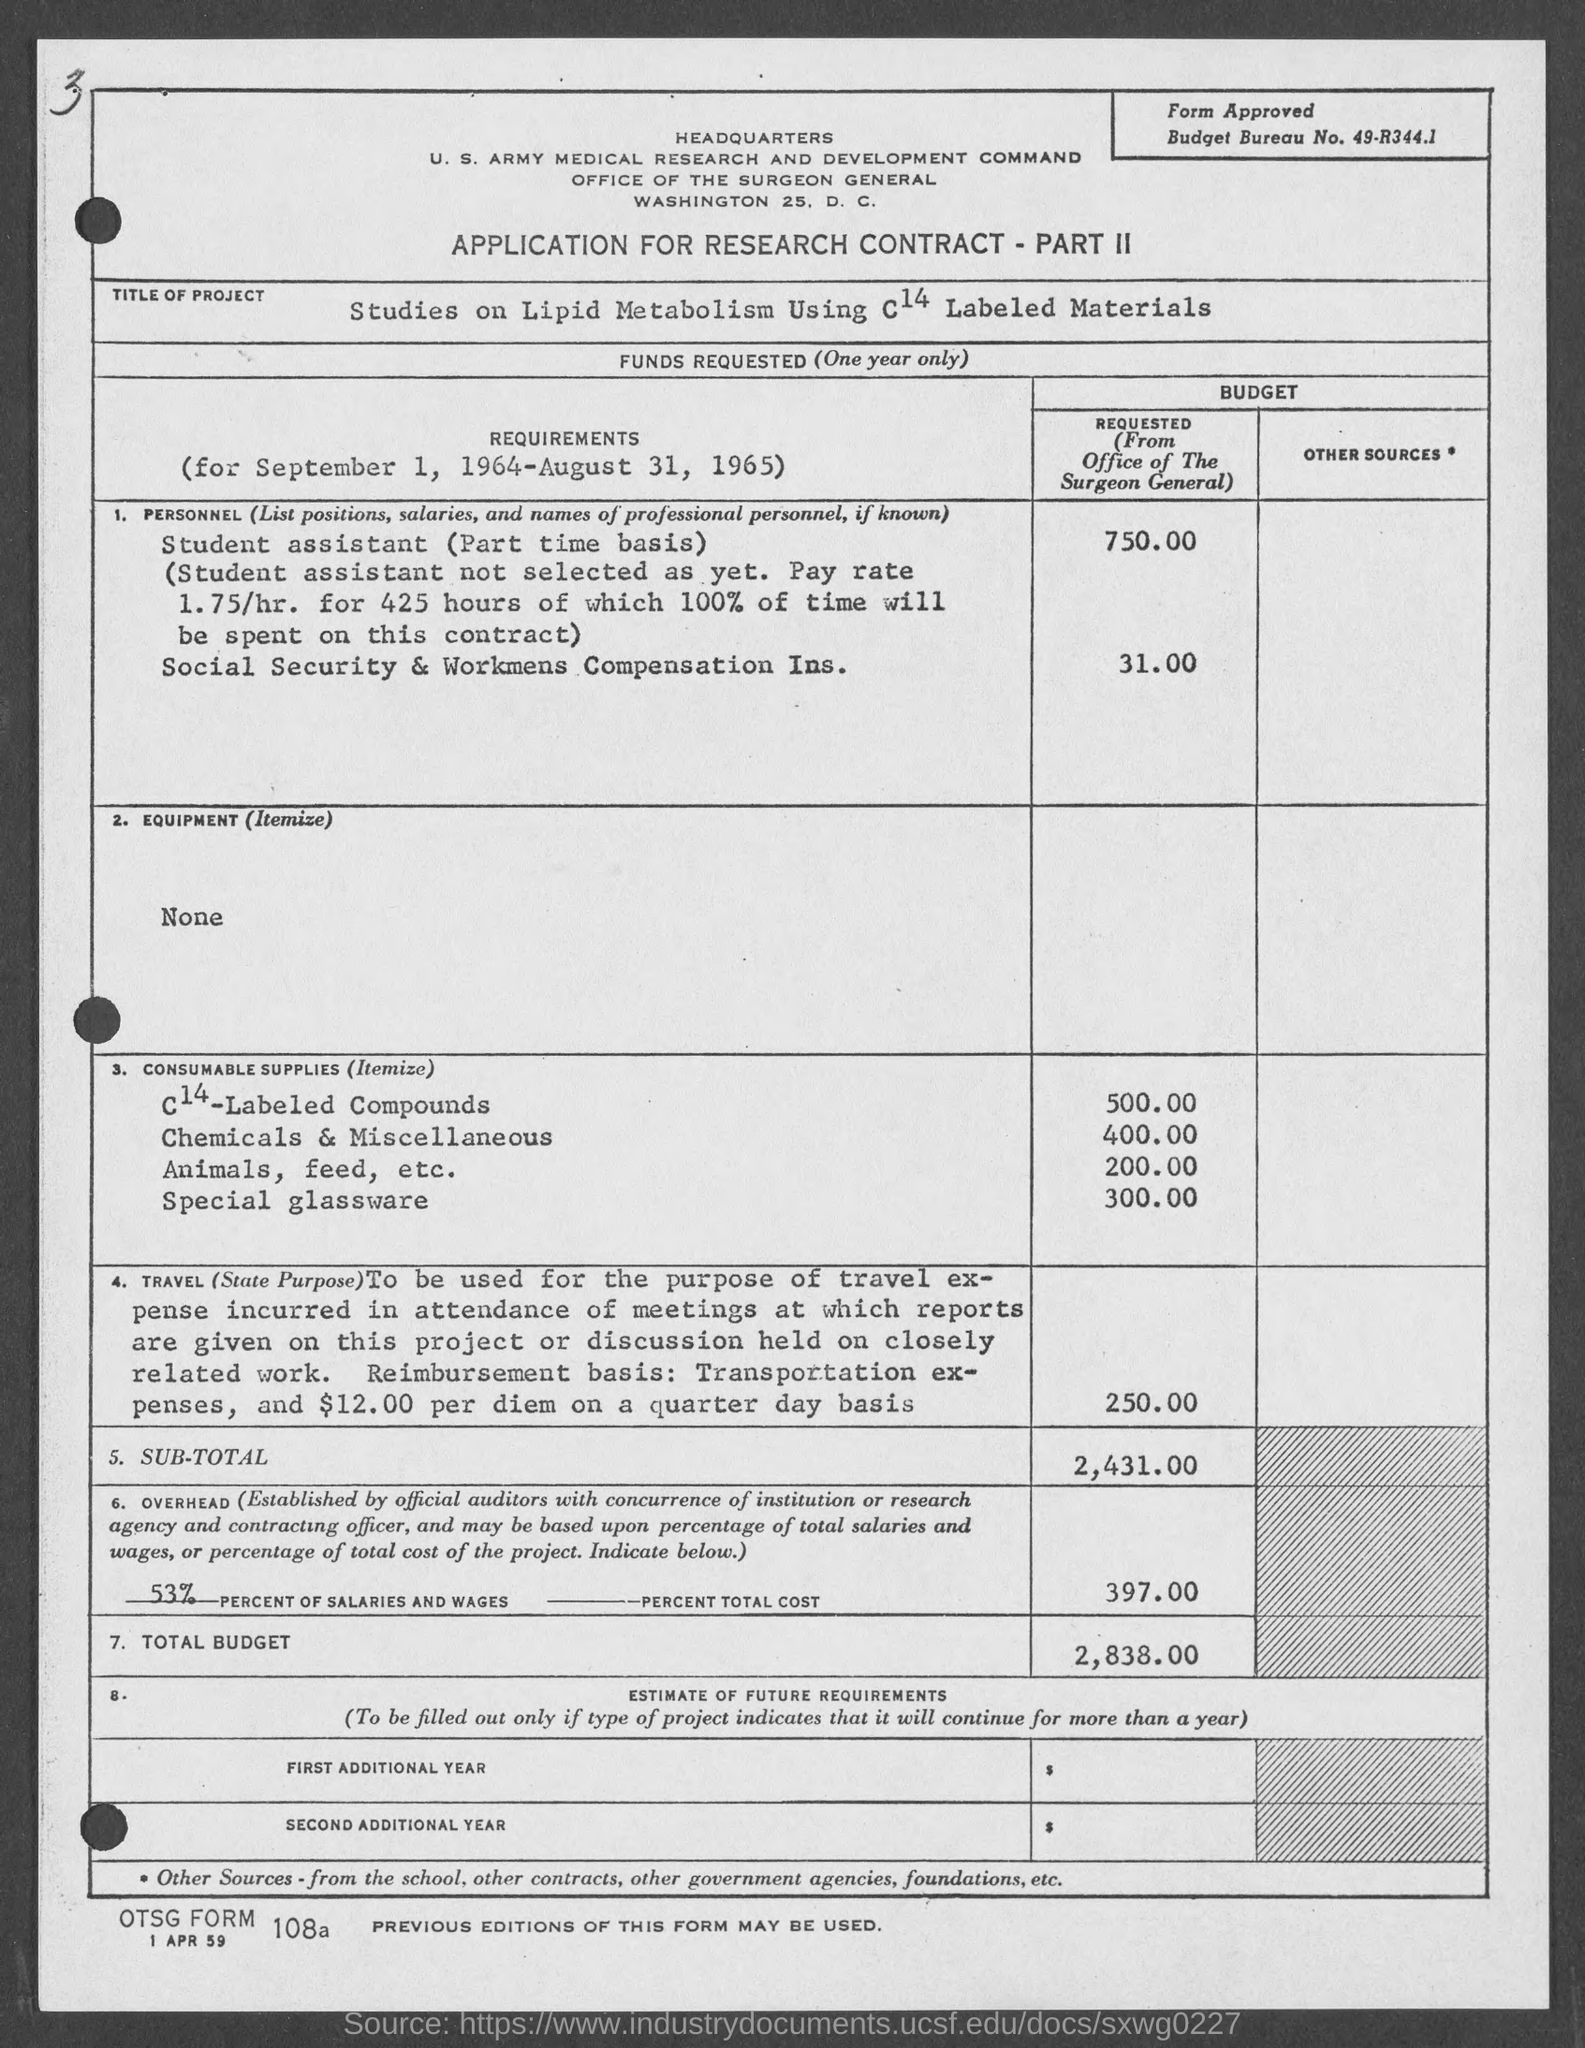What is the percent of salaries and wages as mentioned in the given page ?
Your answer should be compact. 53%. What is the amount for c14- labeled compounds as mentioned in the given form ?
Ensure brevity in your answer.  500.00. What is the amount for chemicals & miscellaneous as mentioned in the given page ?
Your answer should be very brief. 400.00. What is the amount of total budget mentioned in the given page ?
Provide a succinct answer. 2,838.00. What is the amount for animals, feed , etc as mentioned in the given form ?
Ensure brevity in your answer.  200.00. What is the amount for special glassware as mentioned in the given form ?
Make the answer very short. 300.00. 